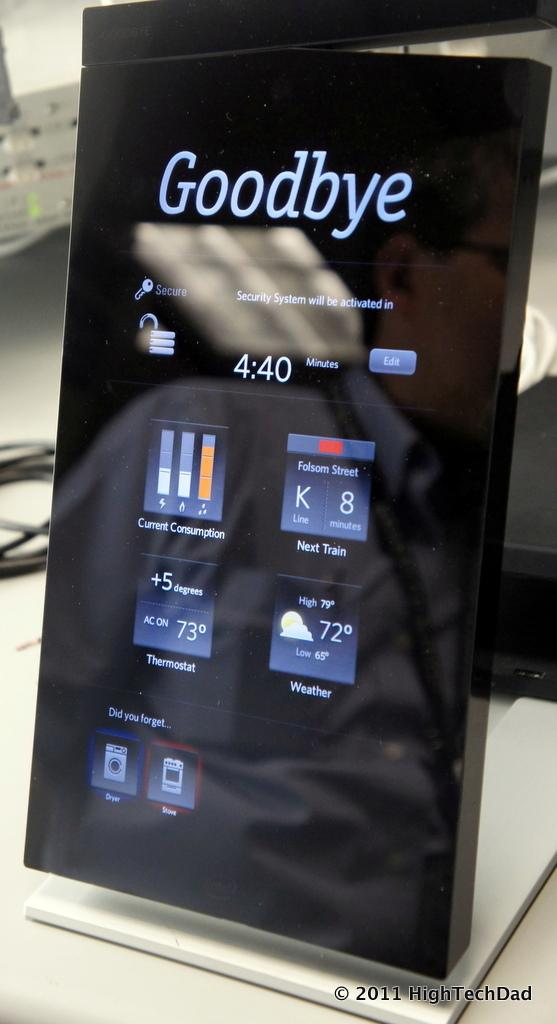<image>
Create a compact narrative representing the image presented. The phone shown on display says the word goodbye on it. 